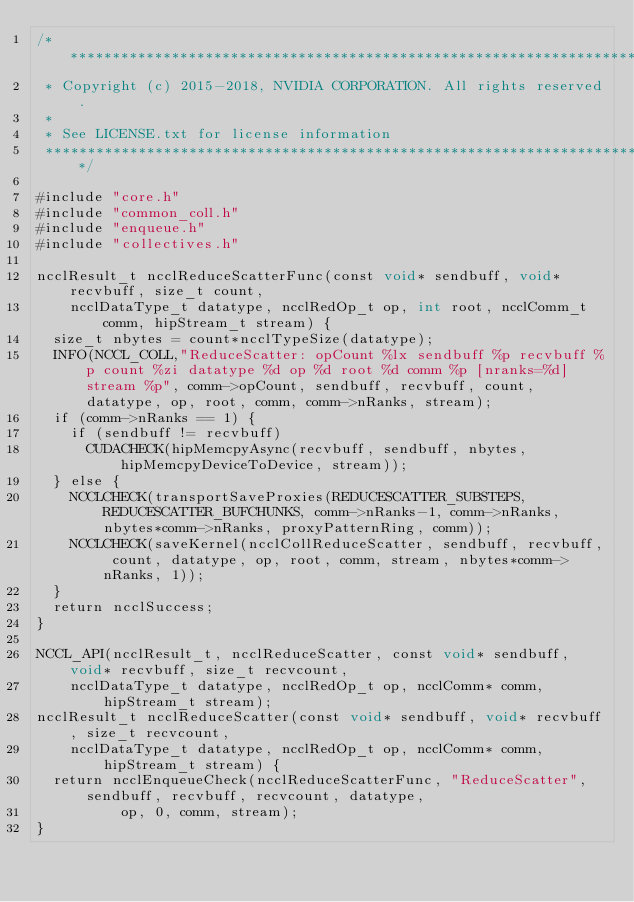<code> <loc_0><loc_0><loc_500><loc_500><_Cuda_>/*************************************************************************
 * Copyright (c) 2015-2018, NVIDIA CORPORATION. All rights reserved.
 *
 * See LICENSE.txt for license information
 ************************************************************************/

#include "core.h"
#include "common_coll.h"
#include "enqueue.h"
#include "collectives.h"

ncclResult_t ncclReduceScatterFunc(const void* sendbuff, void* recvbuff, size_t count,
    ncclDataType_t datatype, ncclRedOp_t op, int root, ncclComm_t comm, hipStream_t stream) {
  size_t nbytes = count*ncclTypeSize(datatype);
  INFO(NCCL_COLL,"ReduceScatter: opCount %lx sendbuff %p recvbuff %p count %zi datatype %d op %d root %d comm %p [nranks=%d] stream %p", comm->opCount, sendbuff, recvbuff, count, datatype, op, root, comm, comm->nRanks, stream);
  if (comm->nRanks == 1) {
    if (sendbuff != recvbuff)
      CUDACHECK(hipMemcpyAsync(recvbuff, sendbuff, nbytes, hipMemcpyDeviceToDevice, stream));
  } else {
    NCCLCHECK(transportSaveProxies(REDUCESCATTER_SUBSTEPS, REDUCESCATTER_BUFCHUNKS, comm->nRanks-1, comm->nRanks, nbytes*comm->nRanks, proxyPatternRing, comm));
    NCCLCHECK(saveKernel(ncclCollReduceScatter, sendbuff, recvbuff, count, datatype, op, root, comm, stream, nbytes*comm->nRanks, 1));
  }
  return ncclSuccess;
}

NCCL_API(ncclResult_t, ncclReduceScatter, const void* sendbuff, void* recvbuff, size_t recvcount,
    ncclDataType_t datatype, ncclRedOp_t op, ncclComm* comm, hipStream_t stream);
ncclResult_t ncclReduceScatter(const void* sendbuff, void* recvbuff, size_t recvcount,
    ncclDataType_t datatype, ncclRedOp_t op, ncclComm* comm, hipStream_t stream) {
  return ncclEnqueueCheck(ncclReduceScatterFunc, "ReduceScatter", sendbuff, recvbuff, recvcount, datatype,
          op, 0, comm, stream);
}
</code> 